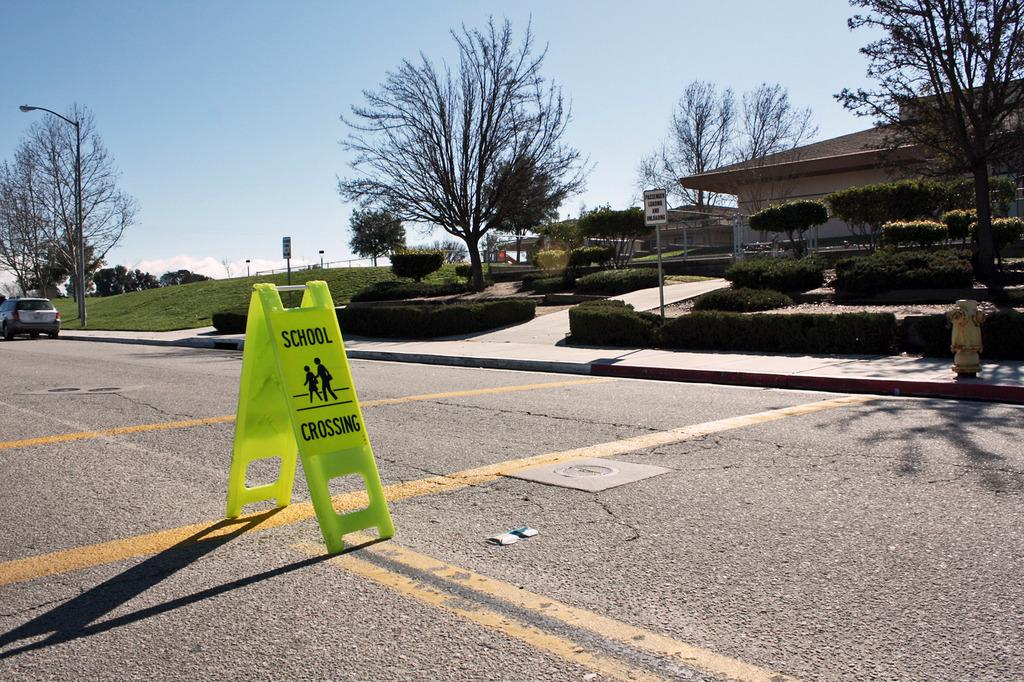What is located on the left side of the image? There is a sign board and a car on the left side of the image. What can be seen in the background of the image? There are plants, houses, trees, poles, and the sky visible in the background of the image. What is present on the right side of the image? There is a water pump on the right side of the image. What type of force is being applied to the minister in the image? There is no minister present in the image, and therefore no force is being applied to anyone. How many oranges are visible in the image? There are no oranges present in the image. 